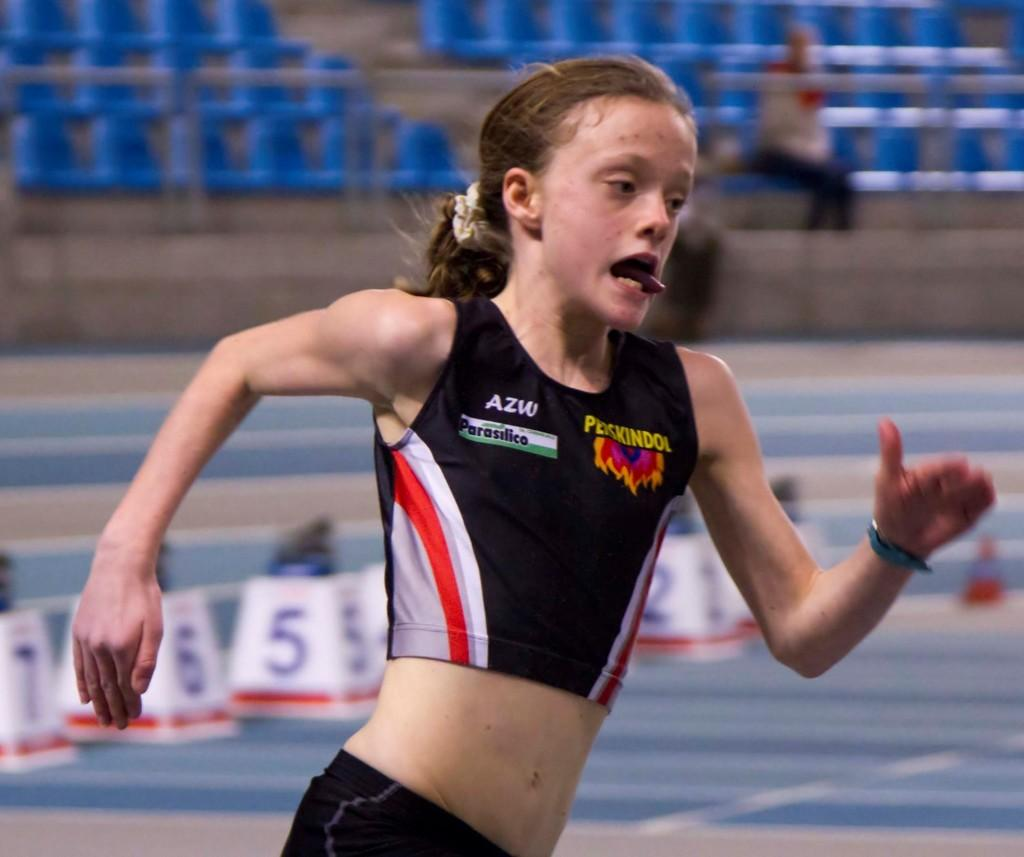Provide a one-sentence caption for the provided image. A runner with her tongue out wears the letters AZW on her right chest. 